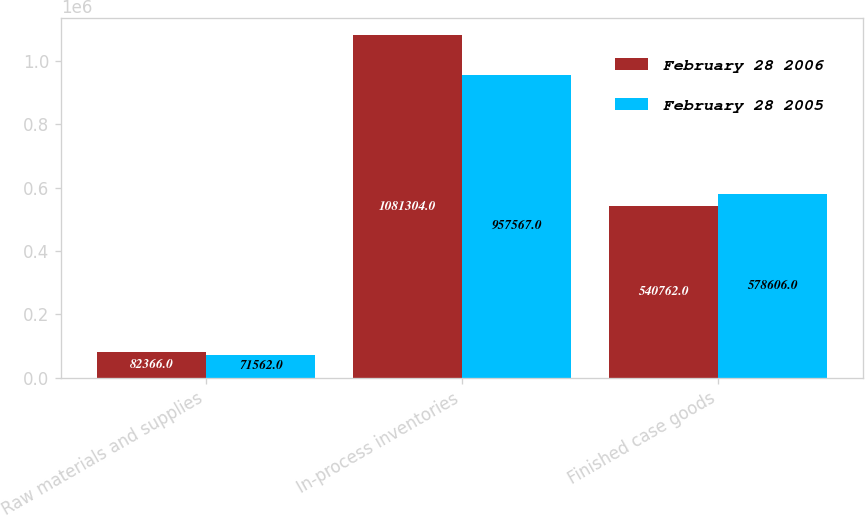Convert chart. <chart><loc_0><loc_0><loc_500><loc_500><stacked_bar_chart><ecel><fcel>Raw materials and supplies<fcel>In-process inventories<fcel>Finished case goods<nl><fcel>February 28 2006<fcel>82366<fcel>1.0813e+06<fcel>540762<nl><fcel>February 28 2005<fcel>71562<fcel>957567<fcel>578606<nl></chart> 